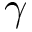<formula> <loc_0><loc_0><loc_500><loc_500>\gamma</formula> 